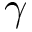<formula> <loc_0><loc_0><loc_500><loc_500>\gamma</formula> 